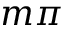<formula> <loc_0><loc_0><loc_500><loc_500>m \pi</formula> 